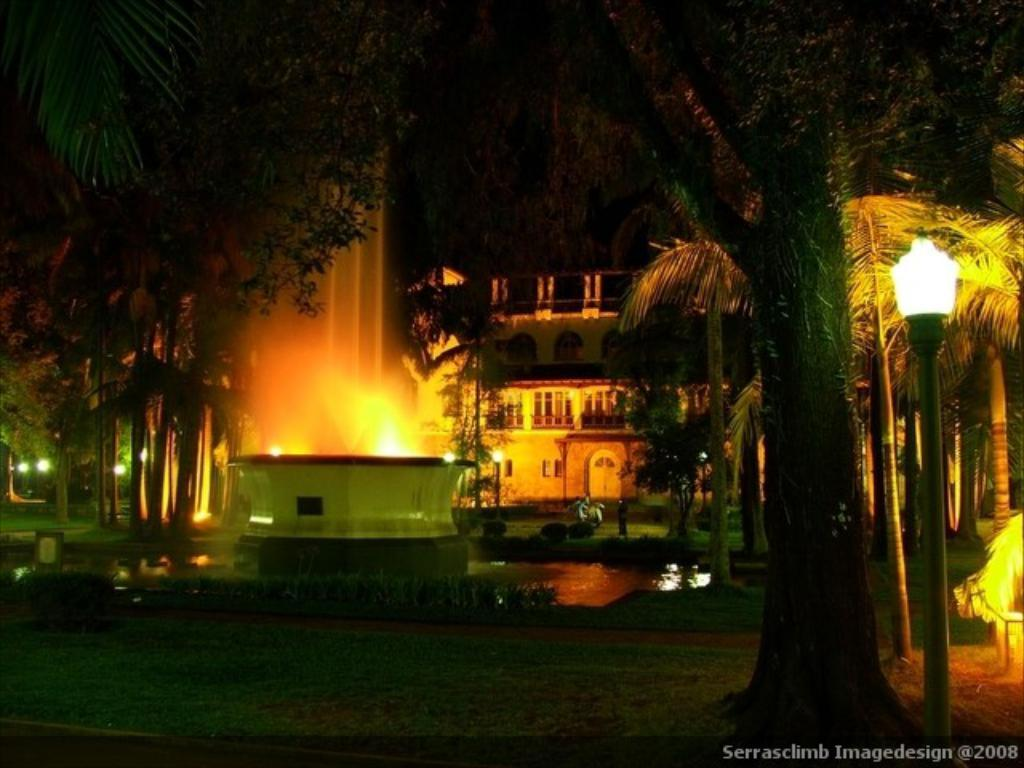What structure is the main focus of the image? There is a building in the image. What is located in front of the building? There is a fountain in front of the building. What type of vegetation can be seen in the image? Trees and plants are visible in the image. What type of lighting is present in the image? There are street lights in the image. What can be observed about the background of the image? The background of the image is dark. What type of lead can be seen being transported by the trains in the image? There are: There are no trains present in the image, so it is not possible to determine if any lead is being transported. 